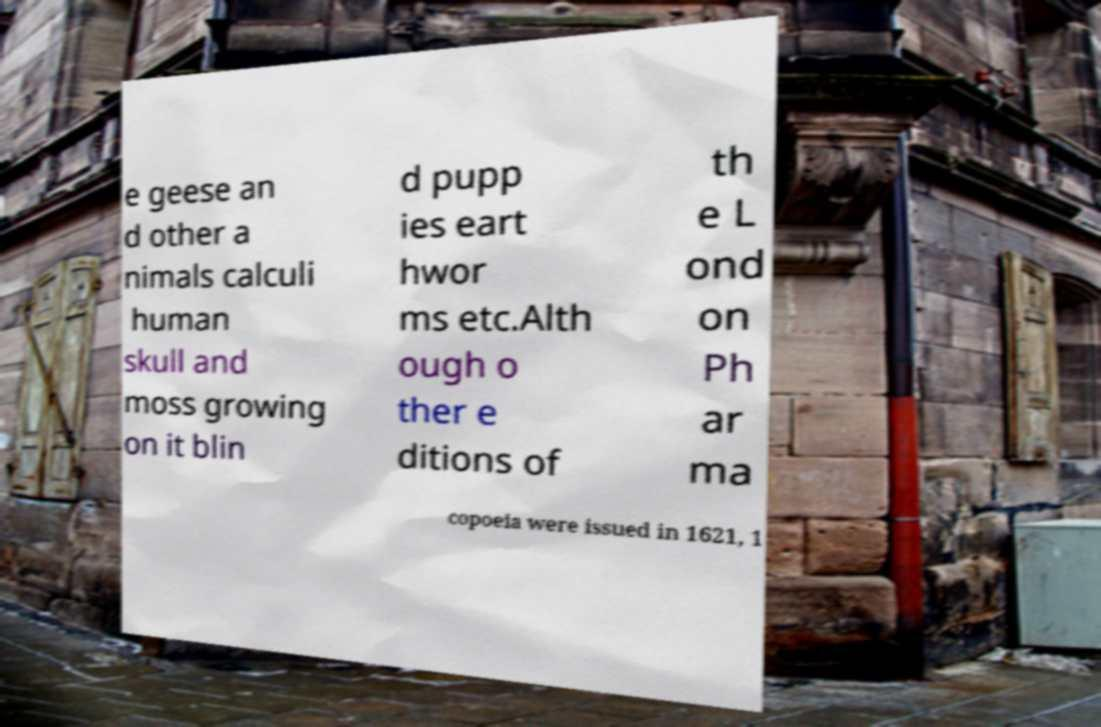There's text embedded in this image that I need extracted. Can you transcribe it verbatim? e geese an d other a nimals calculi human skull and moss growing on it blin d pupp ies eart hwor ms etc.Alth ough o ther e ditions of th e L ond on Ph ar ma copoeia were issued in 1621, 1 